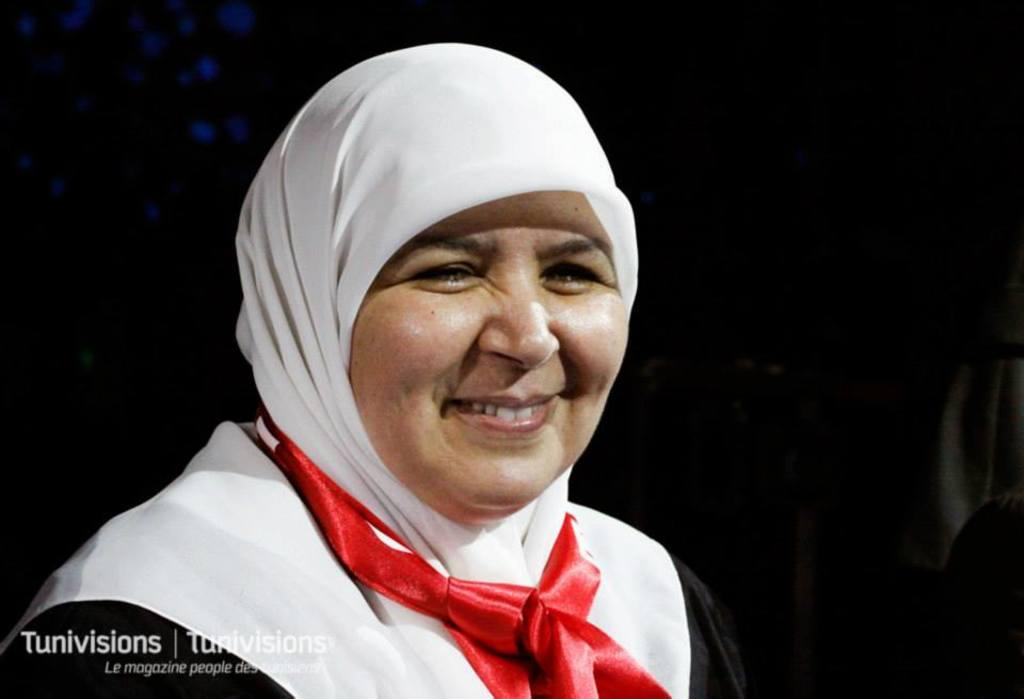Who is present in the image? There is a woman in the image. What is the woman wearing? The woman is wearing clothes. What expression does the woman have? The woman is smiling. What can be seen in the background of the image? The background of the image is dark. Is there any additional information or marking in the image? Yes, there is a watermark in the bottom left corner of the image. Can you see any visible veins on the woman's hands in the image? There is no information about the woman's hands or veins in the image, so it cannot be determined from the image. 